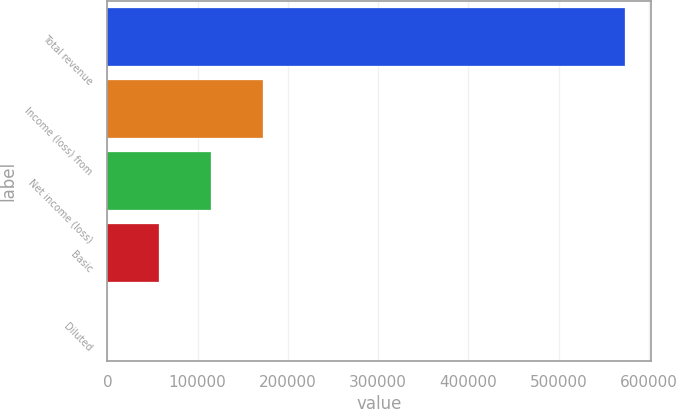Convert chart to OTSL. <chart><loc_0><loc_0><loc_500><loc_500><bar_chart><fcel>Total revenue<fcel>Income (loss) from<fcel>Net income (loss)<fcel>Basic<fcel>Diluted<nl><fcel>573225<fcel>171968<fcel>114645<fcel>57322.8<fcel>0.38<nl></chart> 